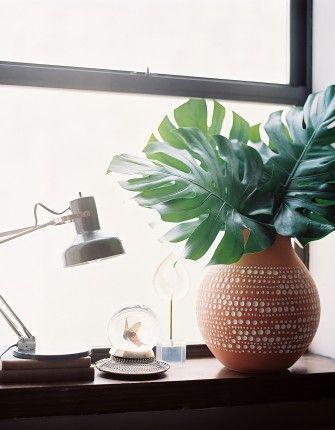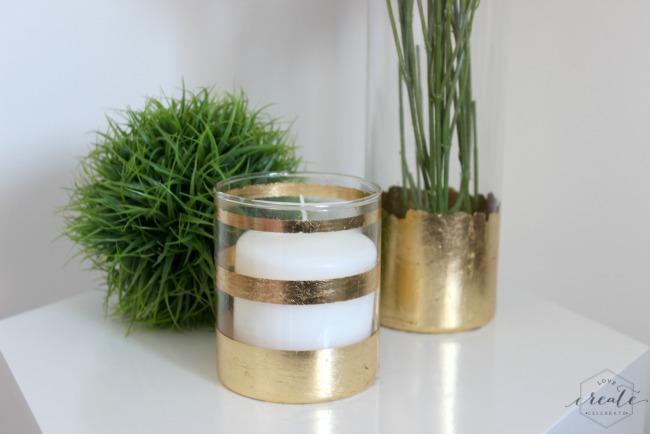The first image is the image on the left, the second image is the image on the right. Examine the images to the left and right. Is the description "At least one of the images shows one or more candles next to a plant." accurate? Answer yes or no. Yes. The first image is the image on the left, the second image is the image on the right. Evaluate the accuracy of this statement regarding the images: "In one of the image there is vase with a plant in it in front of a window.". Is it true? Answer yes or no. Yes. 